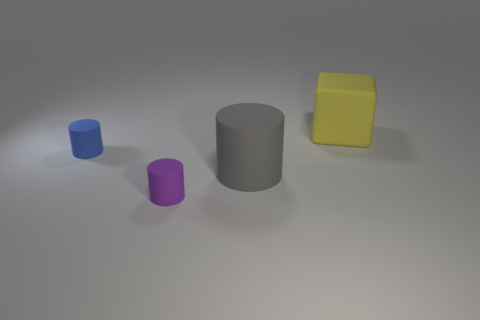How are the objects arranged in the image? The objects are arranged from left to right, with the blue cylinder being the smallest and farthest to the left. The purple cylinder is next, followed by the larger gray cylinder in the center. The yellow cuboid is positioned to the right of the gray cylinder. 